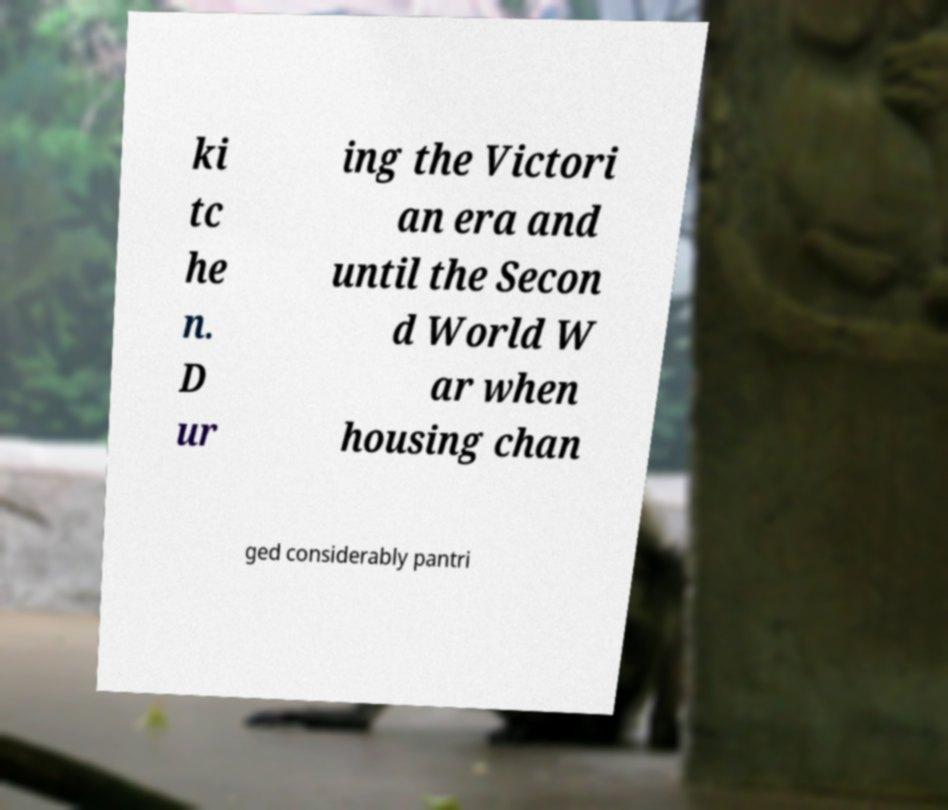Can you read and provide the text displayed in the image?This photo seems to have some interesting text. Can you extract and type it out for me? ki tc he n. D ur ing the Victori an era and until the Secon d World W ar when housing chan ged considerably pantri 